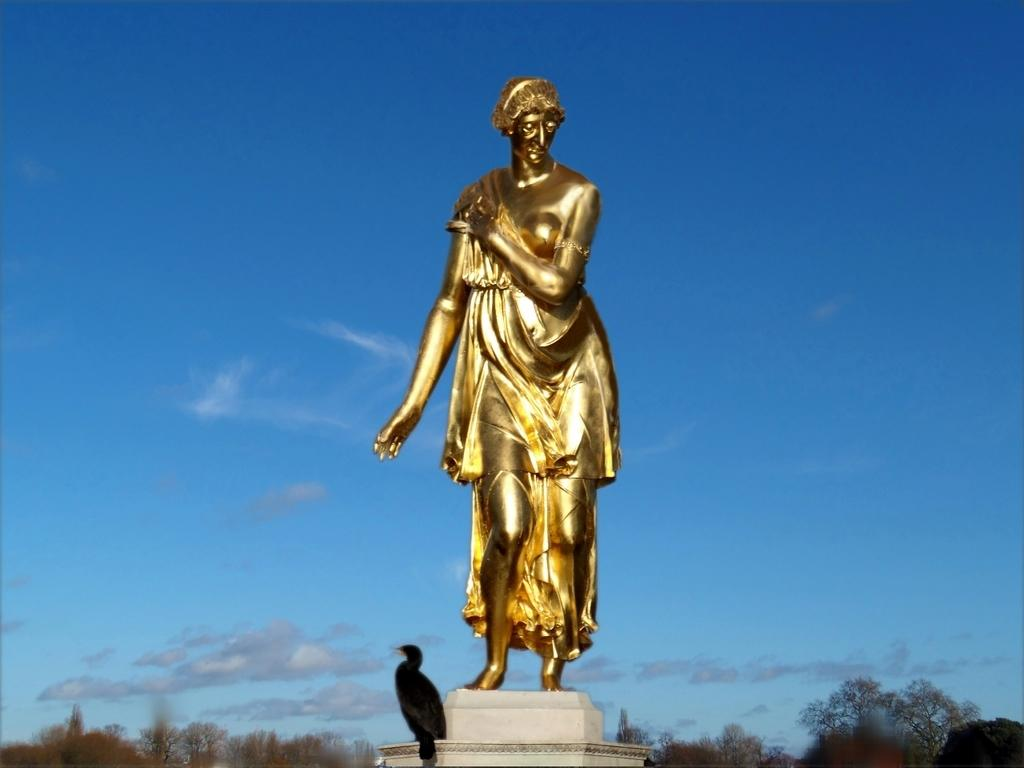What is the main subject of the image? There is a sculpture of a person standing in the image. What other living creature can be seen in the image? There is a bird visible in the image. What type of vegetation is present in the image? There are trees in the image. What is visible in the background of the image? The sky is visible in the image. What type of bridge can be seen in the image? There is no bridge present in the image. What kind of feast is being prepared in the image? There is no feast or preparation for a feast visible in the image. 